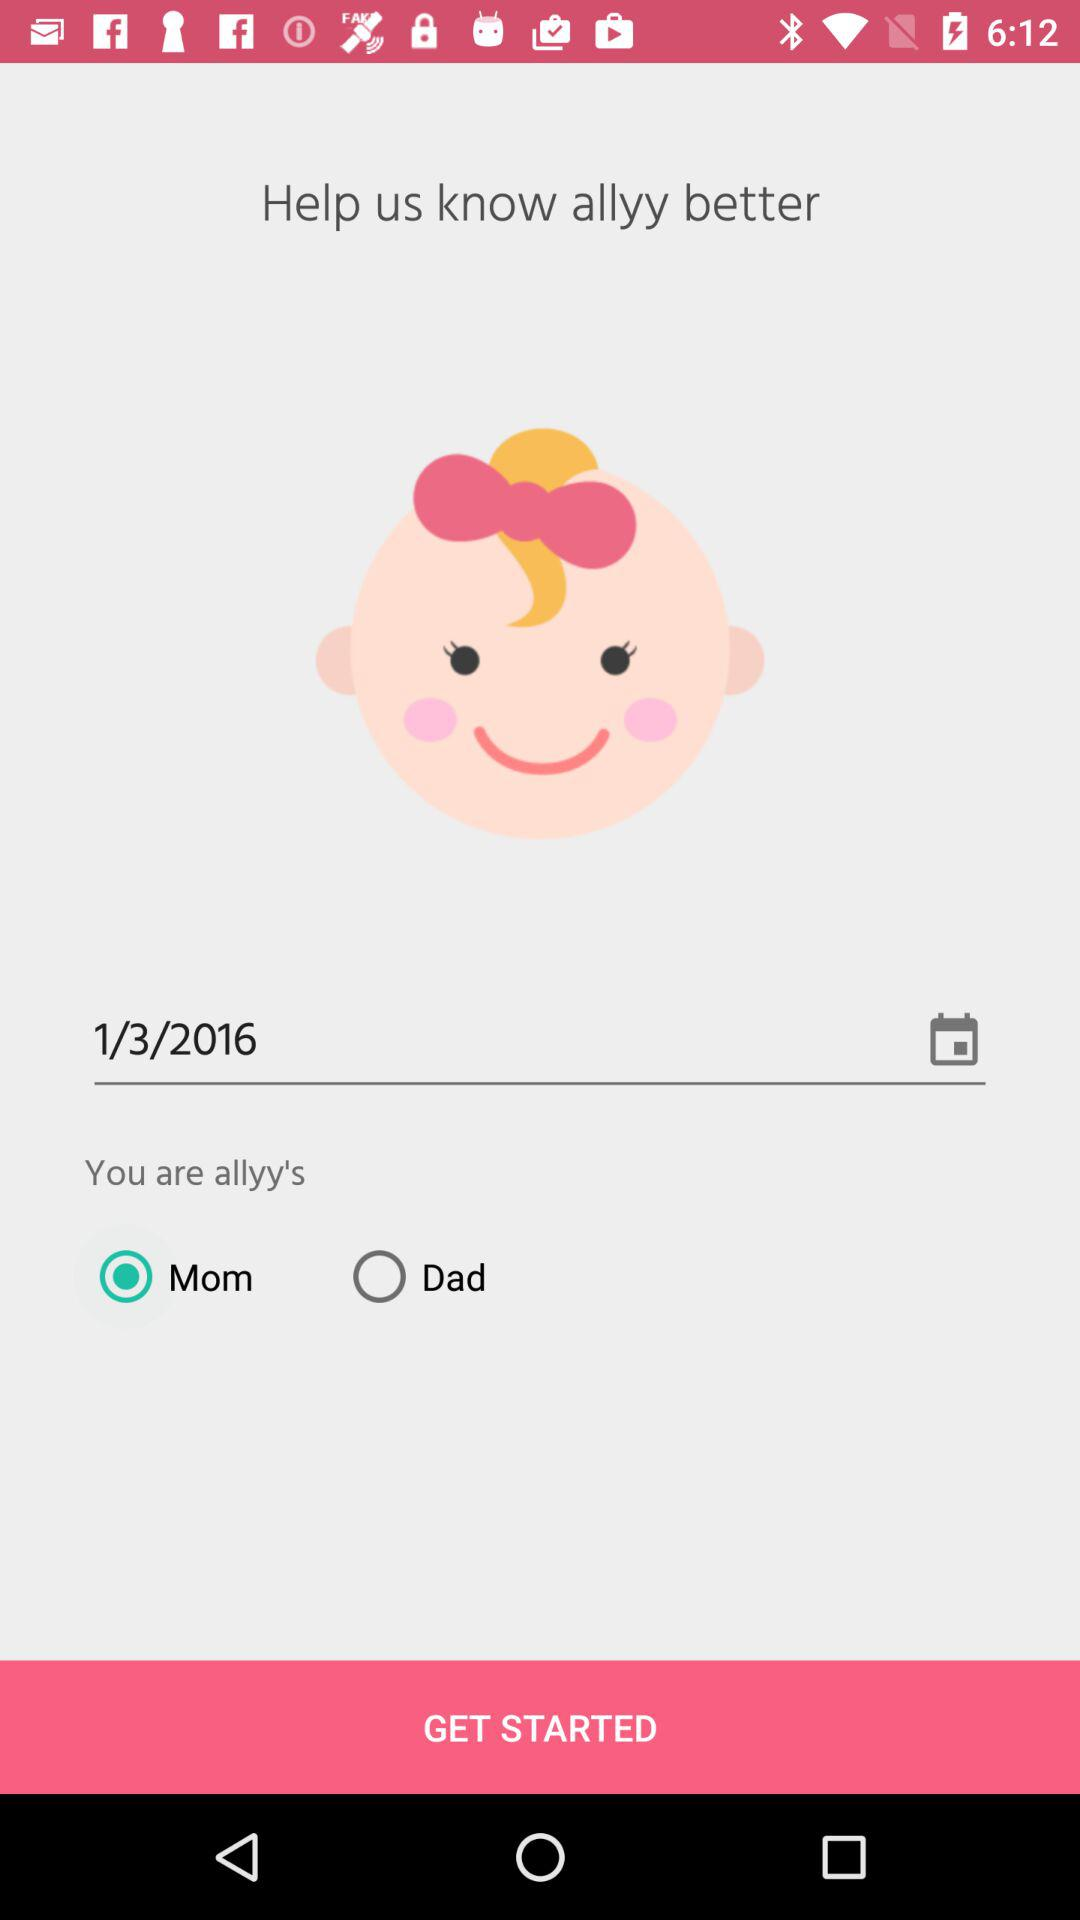What date is selected for the process? The selected date for the process is January 3, 2016. 